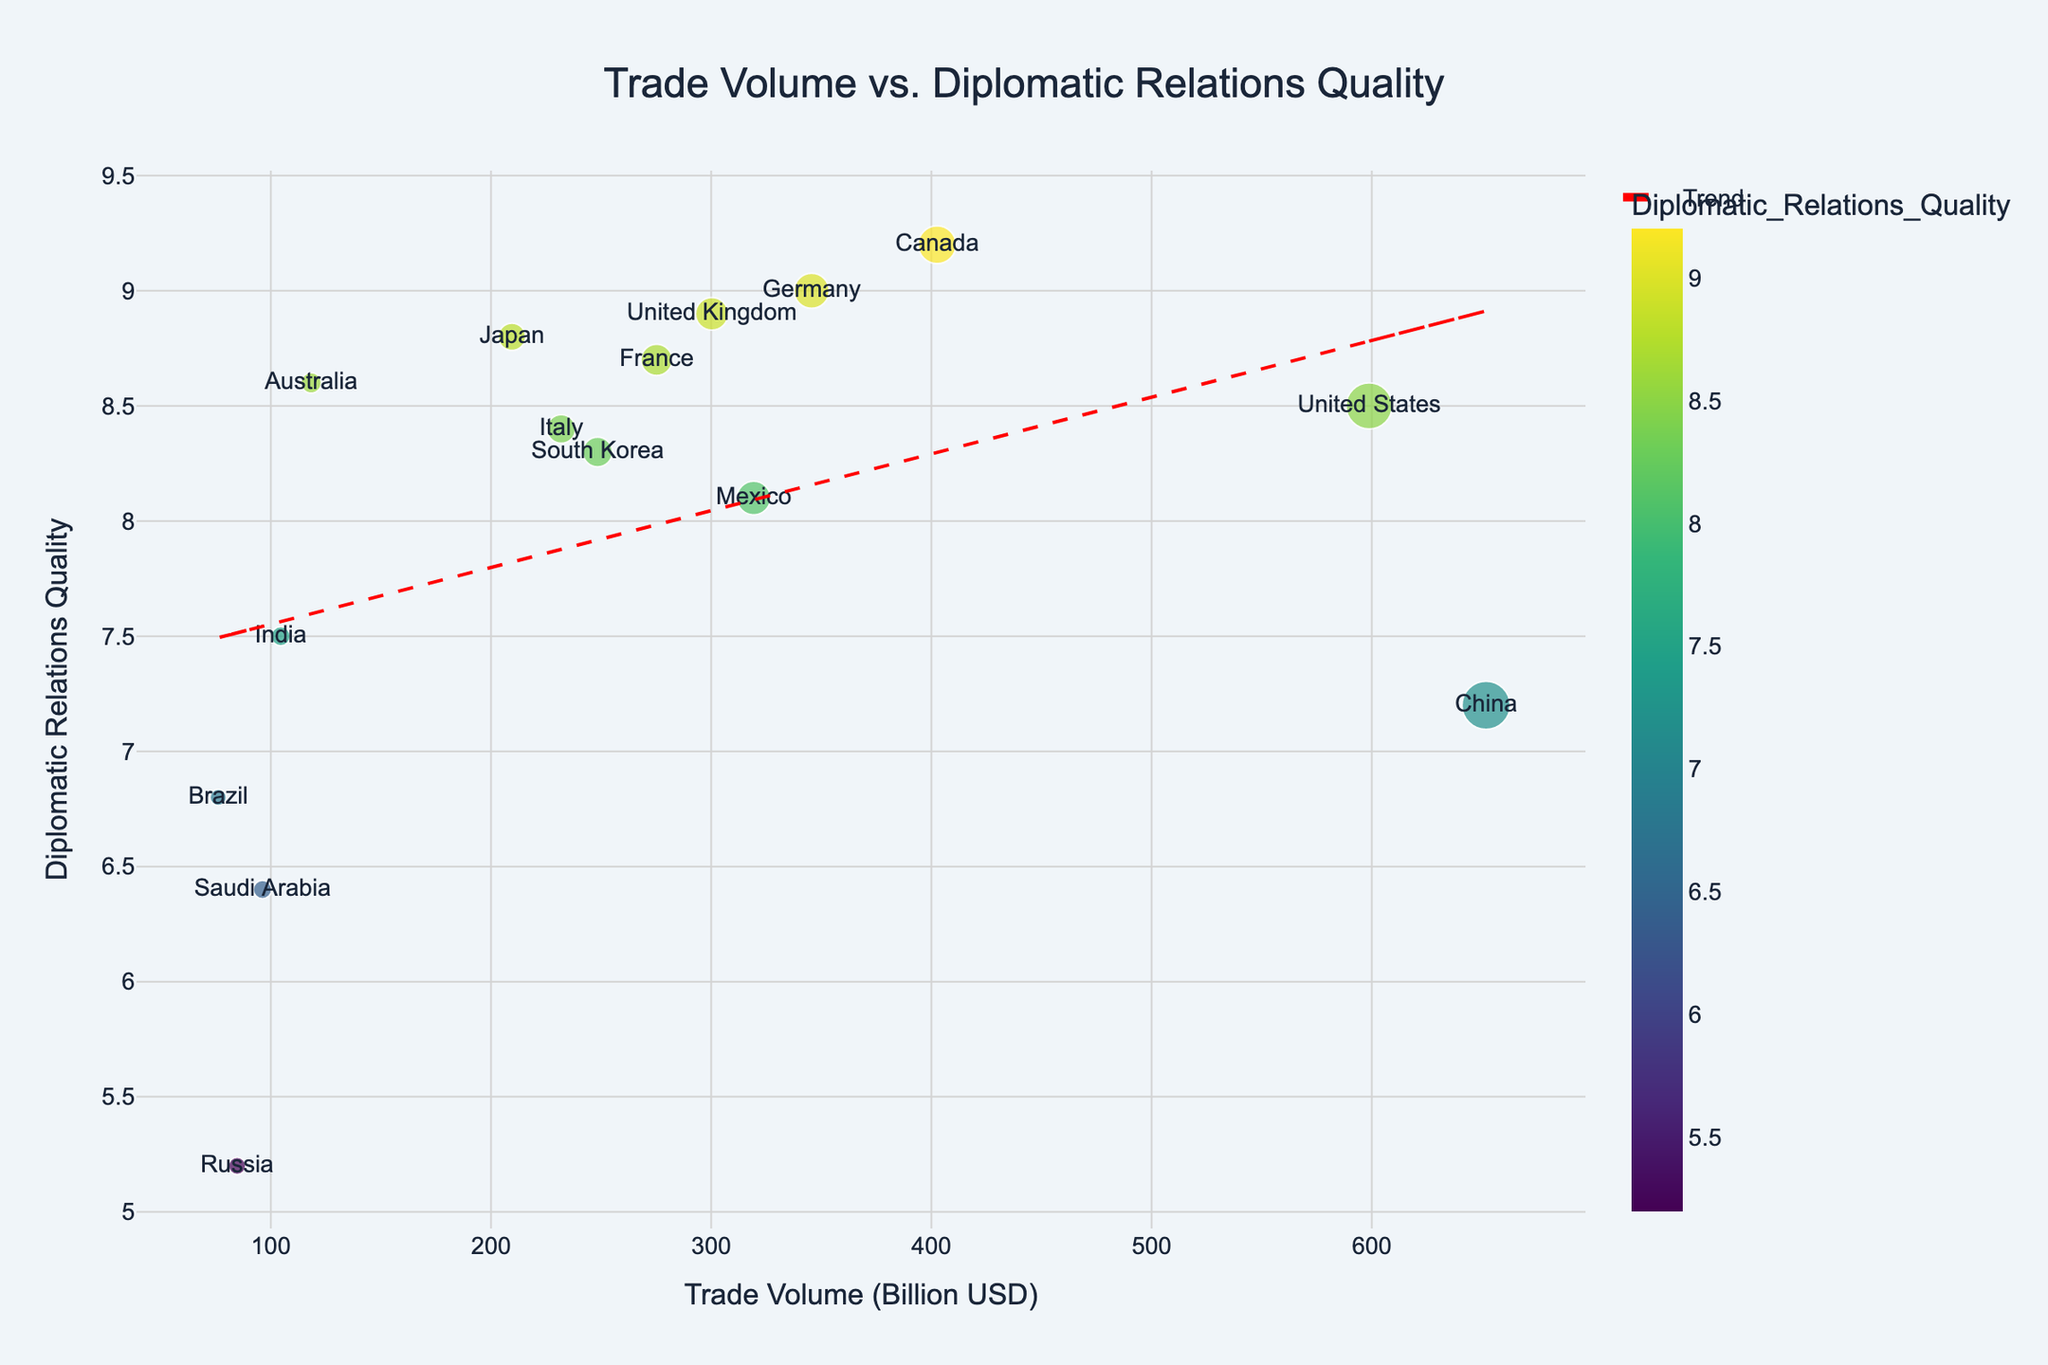What is the title of the scatter plot? The title is usually displayed at the top center of the plot. It gives a brief description of what the chart represents. In this case, it reads "Trade Volume vs. Diplomatic Relations Quality".
Answer: "Trade Volume vs. Diplomatic Relations Quality" How many countries are represented in the scatter plot? By counting the different data points labeled with country names, we can see there are a total of 15 countries represented.
Answer: 15 Which country has the highest trade volume? By observing the x-axis values and the corresponding points, the country with the highest trade volume is labeled, which is China at around 651.9 billion USD.
Answer: China Which country has the lowest quality of diplomatic relations? By looking at the y-axis and identifying the lowest value, the country labeled in this position is Russia, with a diplomatic relations quality of approximately 5.2.
Answer: Russia Does there appear to be a trend between trade volume and diplomatic relations quality? By observing the scatter plot and the trend line (red dashed line), we can see that there is a slightly positive trend, suggesting that higher trade volume tends to correlate with better diplomatic relations quality.
Answer: Yes What is the trade volume of the United States and its diplomatic relations quality? By finding the point labeled "United States" and referring to its x and y coordinates, we see the trade volume is approximately 598.8 billion USD and diplomatic relations quality is 8.5.
Answer: 598.8 billion USD, 8.5 Which countries have a diplomatic relations quality greater than 8.5? By examining the data points above the y-axis value of 8.5, we can identify Germany, Japan, United Kingdom, France, Canada, and Australia.
Answer: Germany, Japan, United Kingdom, France, Canada, Australia Is the trade volume of Brazil or Russia higher, and by how much? By comparing the x-axis positions for Brazil and Russia, we see that Russia's trade volume is 84.7 billion USD, while Brazil's is 76.1 billion USD. The difference is therefore 84.7 - 76.1 = 8.6 billion USD.
Answer: Russia by 8.6 billion USD What is the average diplomatic relations quality for countries with a trade volume above 300 billion USD? First, identify the countries with trade volume above 300 billion USD: United States, China, Germany, United Kingdom, Canada, Mexico. Then, sum their diplomatic relations qualities (8.5 + 7.2 + 9.0 + 8.9 + 9.2 + 8.1) and divide by 6.  The result is (8.5 + 7.2 + 9.0 + 8.9 + 9.2 + 8.1) / 6 = 8.48.
Answer: 8.48 Are there any outliers in the plot in terms of trade volume or diplomatic relations quality? By examining the plot for points that are significantly distant from others, Russia stands out with low diplomatic relations quality (5.2) and China with the highest trade volume (651.9 billion USD). These points are relatively extreme compared to others.
Answer: Russia and China 